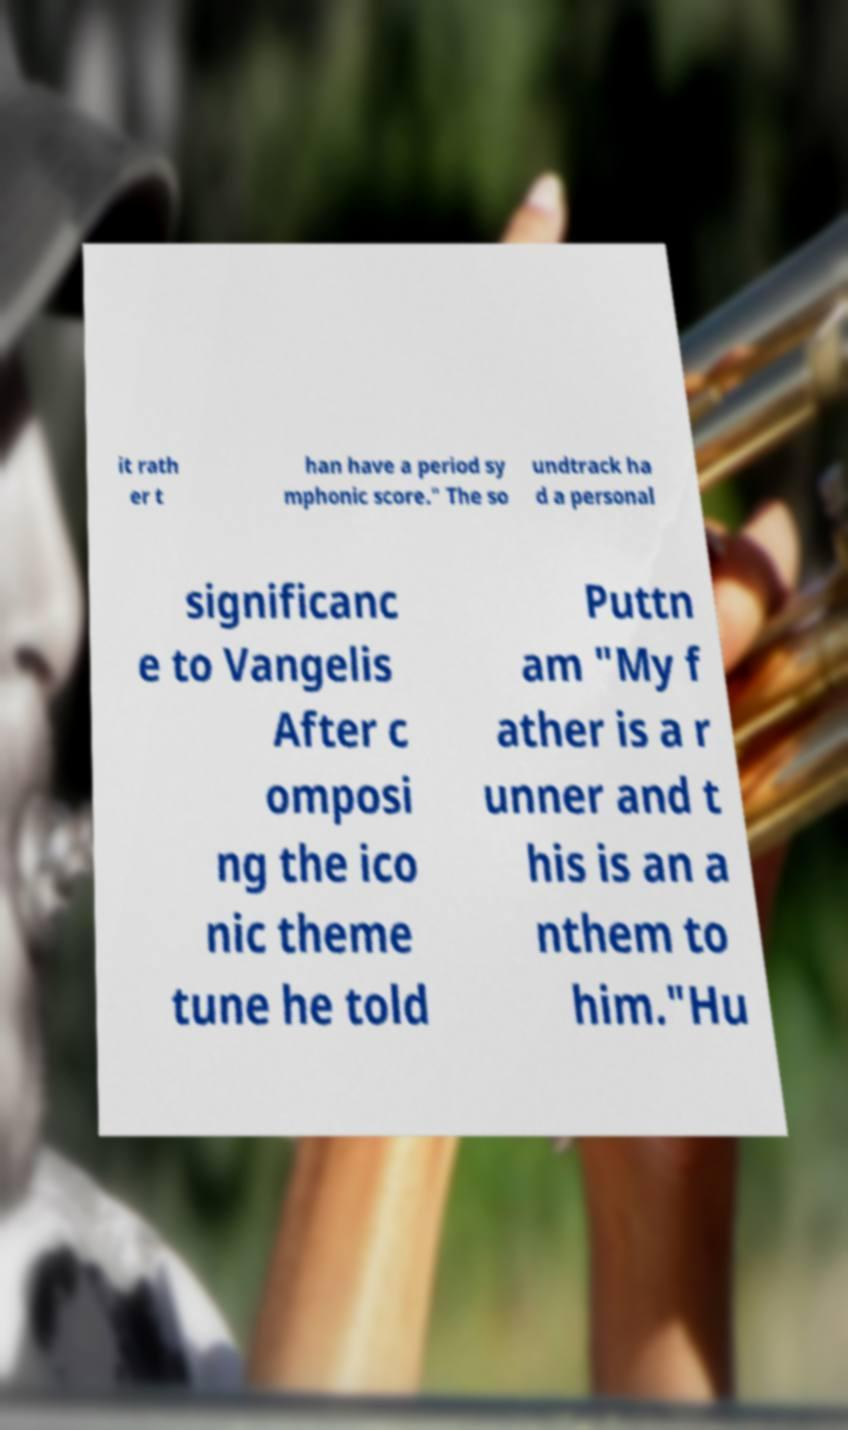Could you extract and type out the text from this image? it rath er t han have a period sy mphonic score." The so undtrack ha d a personal significanc e to Vangelis After c omposi ng the ico nic theme tune he told Puttn am "My f ather is a r unner and t his is an a nthem to him."Hu 